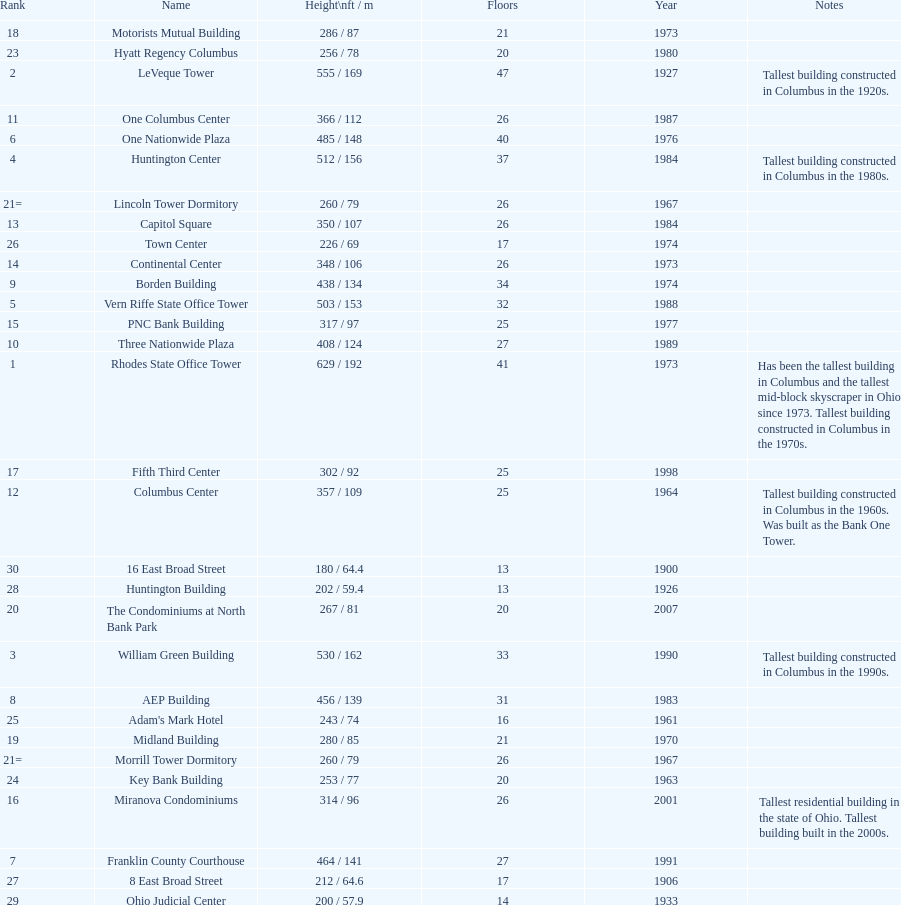Which is taller, the aep building or the one columbus center? AEP Building. 